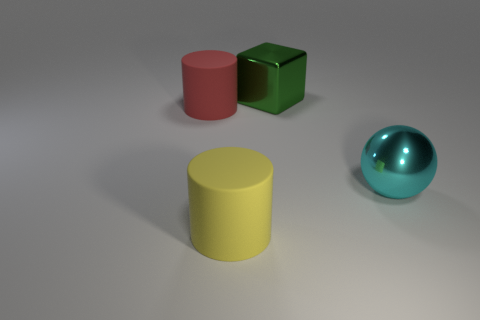Subtract 1 cylinders. How many cylinders are left? 1 Add 4 small brown metal cylinders. How many objects exist? 8 Subtract all spheres. How many objects are left? 3 Subtract all blue cubes. Subtract all gray cylinders. How many cubes are left? 1 Subtract all yellow cylinders. Subtract all big metallic spheres. How many objects are left? 2 Add 3 big yellow matte objects. How many big yellow matte objects are left? 4 Add 2 large green shiny things. How many large green shiny things exist? 3 Subtract 0 blue balls. How many objects are left? 4 